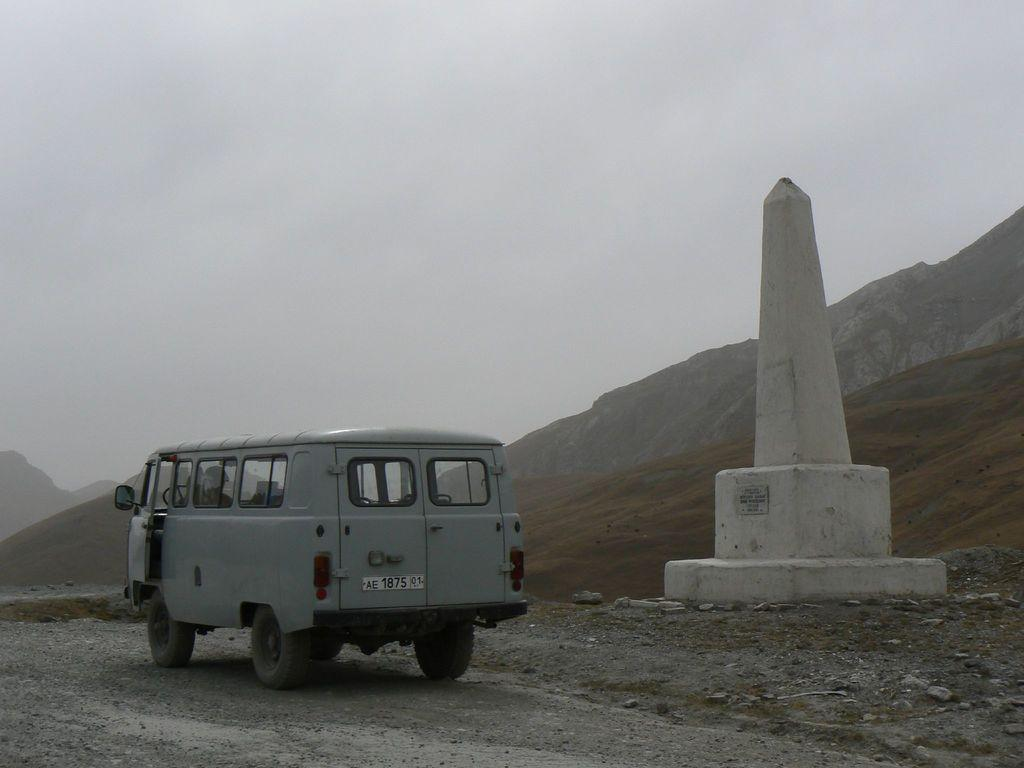What type of vehicle is in the image? There is a van in the image. Where is the van located? The van is on a road. What is beside the van? There is a pillar beside the van. What can be seen in the background of the image? There is a mountain and the sky visible in the background of the image. What type of notebook is on the dashboard of the van? There is no notebook present in the image; it only shows a van on a road with a pillar beside it, a mountain in the background, and the sky visible. 